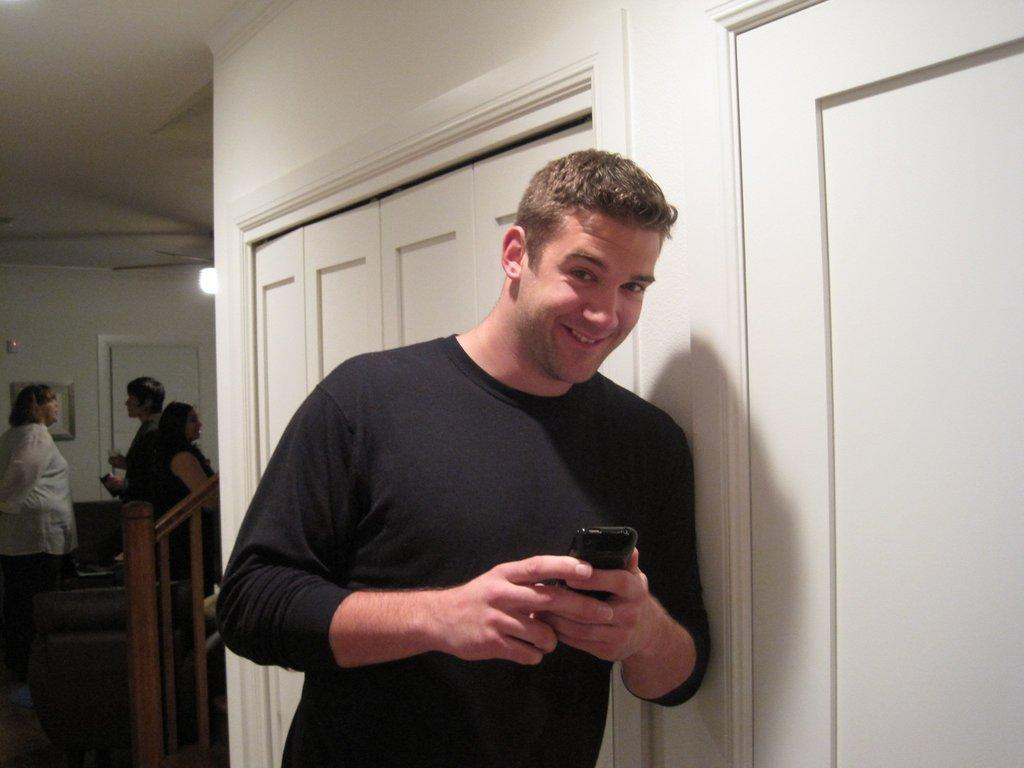What is the main subject in the center of the image? There is a man standing in the center of the image. What is the man holding in the image? The man is holding a mobile. Who else can be seen in the image besides the man? There are people on the left side of the image. What can be seen in the background of the image? There are doors, a wall, and a light in the background of the image. What type of table is being used to create a shocking effect in the image? There is no table present in the image, and no shocking effect can be observed. 